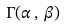<formula> <loc_0><loc_0><loc_500><loc_500>\Gamma ( \alpha \, , \, \beta )</formula> 